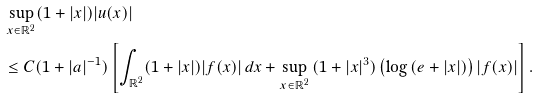<formula> <loc_0><loc_0><loc_500><loc_500>& \sup _ { x \in \mathbb { R } ^ { 2 } } ( 1 + | x | ) | u ( x ) | \\ & \leq C ( 1 + | a | ^ { - 1 } ) \left [ \int _ { \mathbb { R } ^ { 2 } } ( 1 + | x | ) | f ( x ) | \, d x + \sup _ { x \in \mathbb { R } ^ { 2 } } \, ( 1 + | x | ^ { 3 } ) \left ( \log \, ( e + | x | ) \right ) | f ( x ) | \right ] .</formula> 